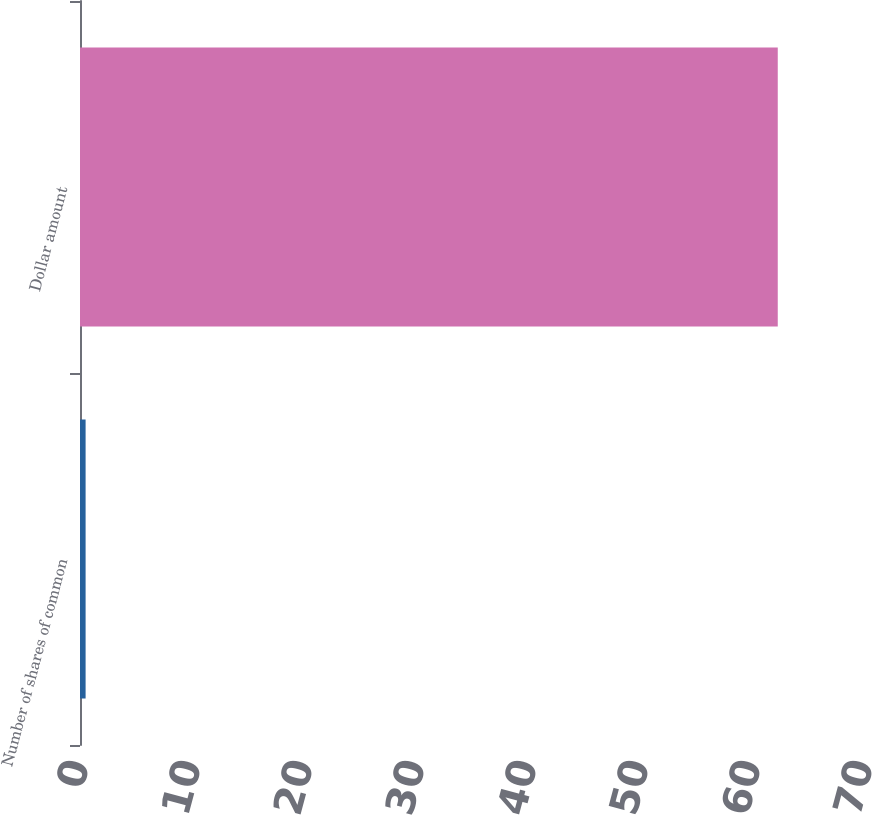Convert chart. <chart><loc_0><loc_0><loc_500><loc_500><bar_chart><fcel>Number of shares of common<fcel>Dollar amount<nl><fcel>0.5<fcel>62.3<nl></chart> 